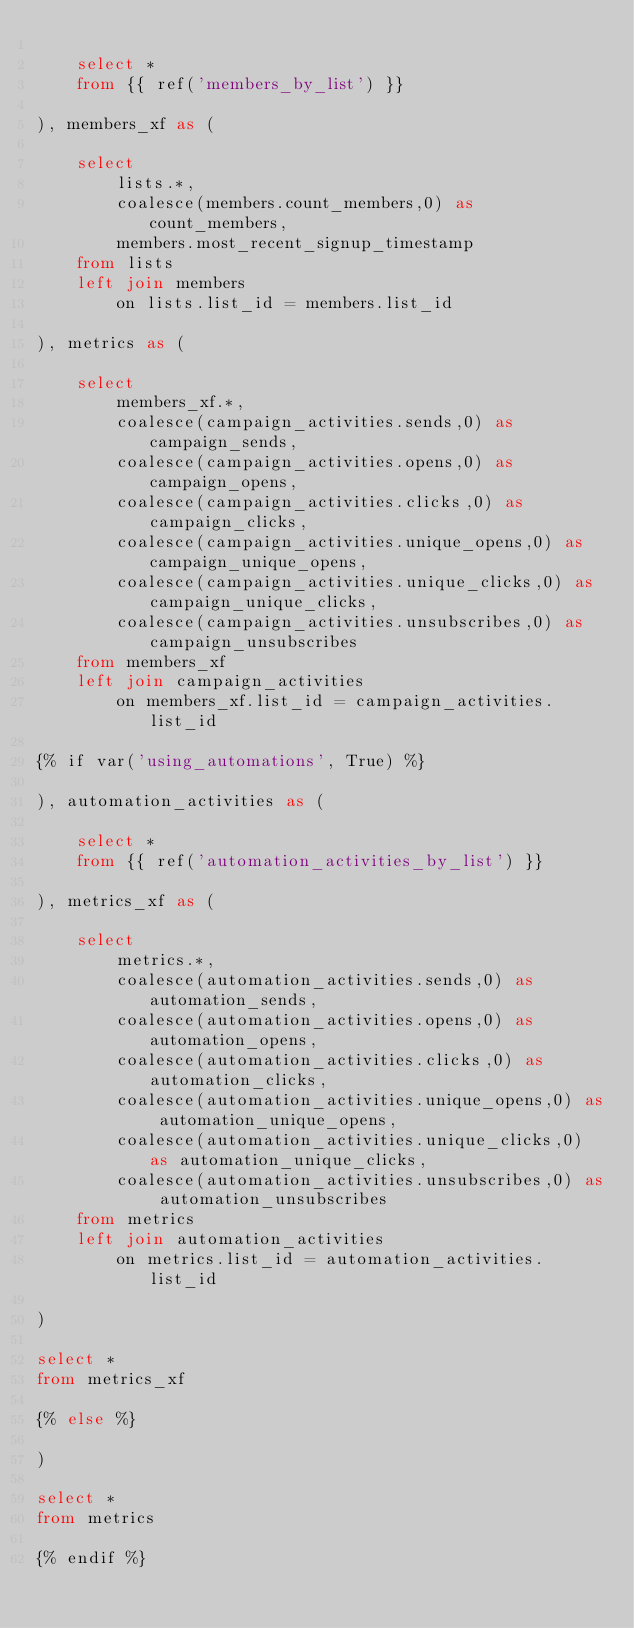Convert code to text. <code><loc_0><loc_0><loc_500><loc_500><_SQL_>
    select *
    from {{ ref('members_by_list') }}

), members_xf as (

    select 
        lists.*,
        coalesce(members.count_members,0) as count_members,
        members.most_recent_signup_timestamp
    from lists
    left join members
        on lists.list_id = members.list_id

), metrics as (

    select 
        members_xf.*,
        coalesce(campaign_activities.sends,0) as campaign_sends,
        coalesce(campaign_activities.opens,0) as campaign_opens,
        coalesce(campaign_activities.clicks,0) as campaign_clicks,
        coalesce(campaign_activities.unique_opens,0) as campaign_unique_opens,
        coalesce(campaign_activities.unique_clicks,0) as campaign_unique_clicks,
        coalesce(campaign_activities.unsubscribes,0) as campaign_unsubscribes
    from members_xf
    left join campaign_activities
        on members_xf.list_id = campaign_activities.list_id

{% if var('using_automations', True) %}

), automation_activities as (

    select *
    from {{ ref('automation_activities_by_list') }}

), metrics_xf as (

    select 
        metrics.*,
        coalesce(automation_activities.sends,0) as automation_sends,
        coalesce(automation_activities.opens,0) as automation_opens,
        coalesce(automation_activities.clicks,0) as automation_clicks,
        coalesce(automation_activities.unique_opens,0) as automation_unique_opens,
        coalesce(automation_activities.unique_clicks,0) as automation_unique_clicks,
        coalesce(automation_activities.unsubscribes,0) as automation_unsubscribes
    from metrics
    left join automation_activities
        on metrics.list_id = automation_activities.list_id

)

select *
from metrics_xf

{% else %}

)

select *
from metrics 

{% endif %}</code> 